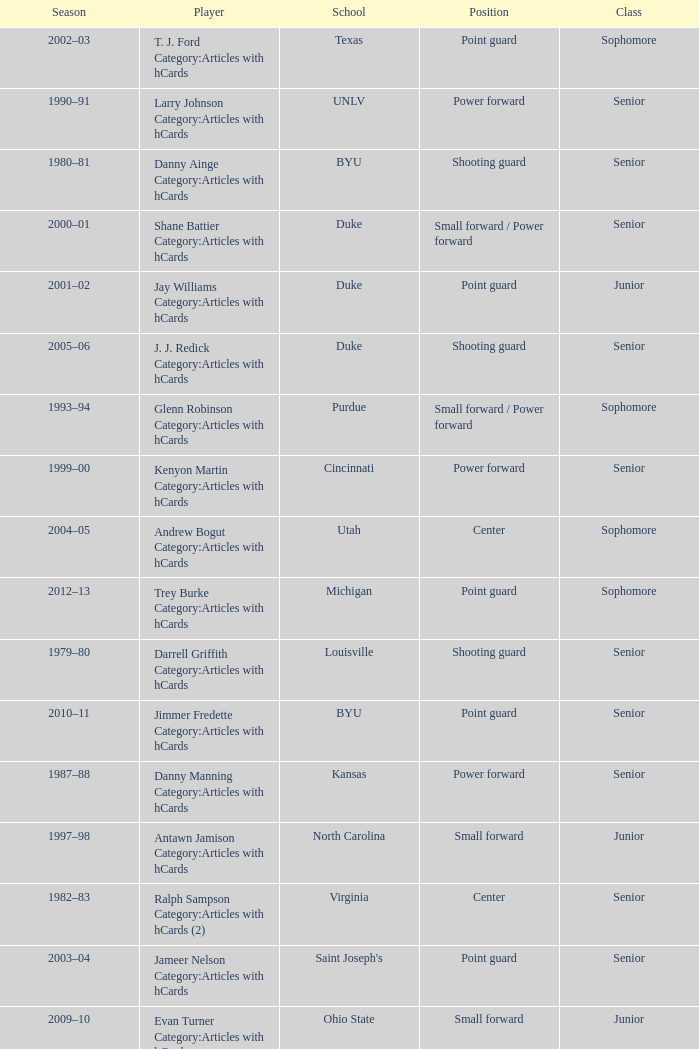Name the position for indiana state Small forward. 